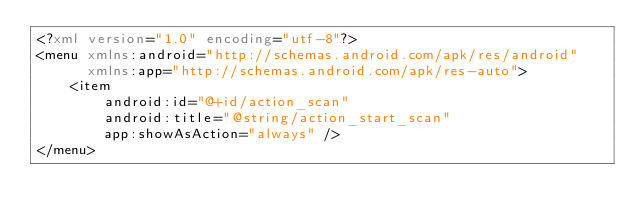Convert code to text. <code><loc_0><loc_0><loc_500><loc_500><_XML_><?xml version="1.0" encoding="utf-8"?>
<menu xmlns:android="http://schemas.android.com/apk/res/android"
      xmlns:app="http://schemas.android.com/apk/res-auto">
    <item
        android:id="@+id/action_scan"
        android:title="@string/action_start_scan"
        app:showAsAction="always" />
</menu></code> 